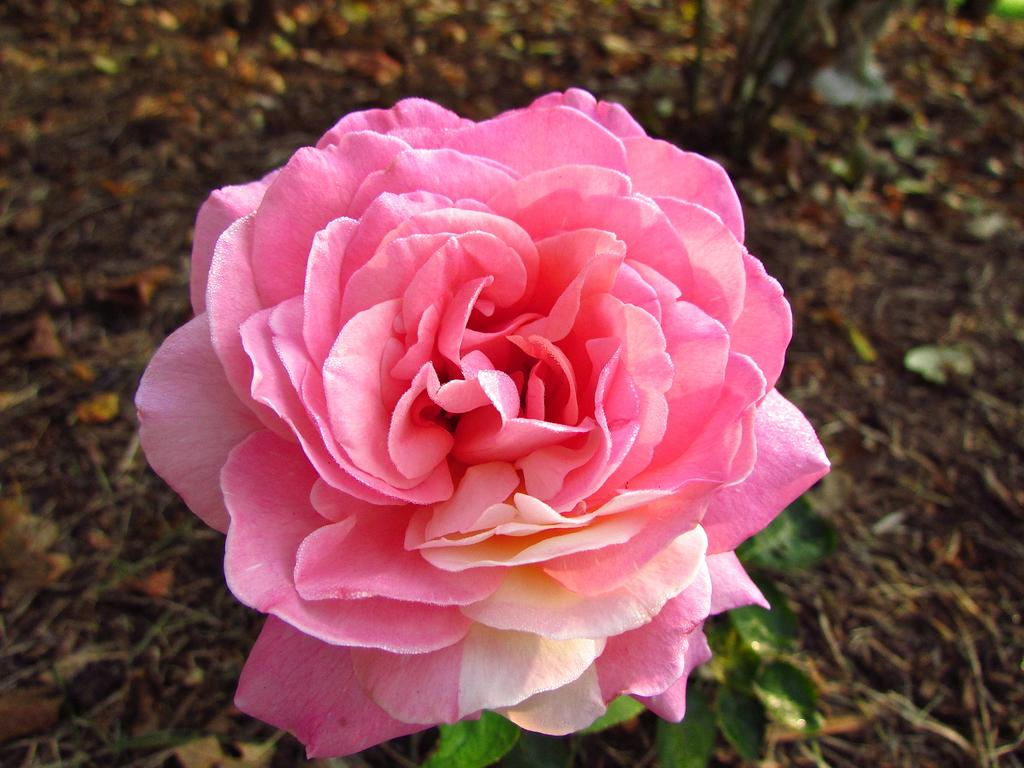What is the main subject of the image? There is a rose in the center of the image. Can you describe the rose in the image? The rose is the main focus of the image and appears to be in full bloom. How many police officers are visible in the image? There are no police officers present in the image; it features a rose. Is there a woman holding the rose in the image? There is no woman visible in the image; it only shows a rose. 